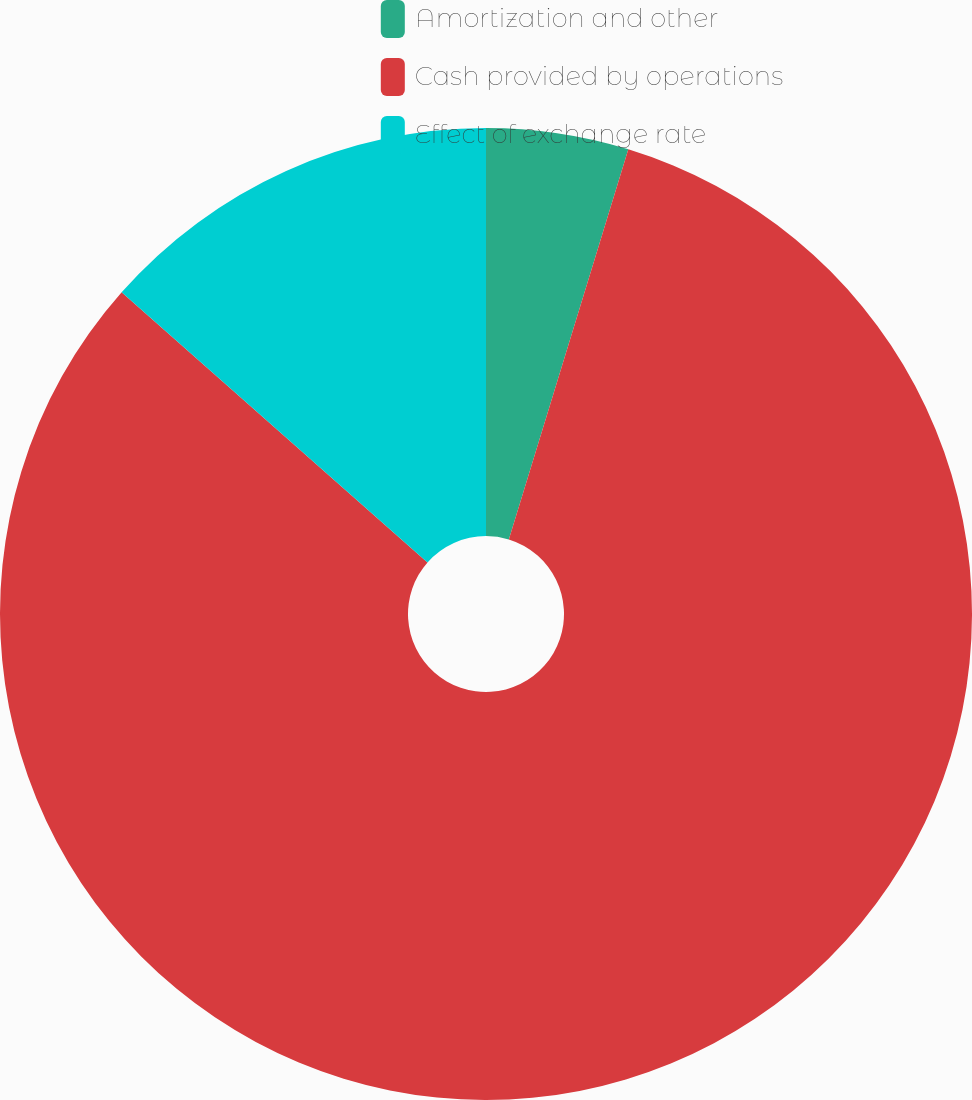Convert chart to OTSL. <chart><loc_0><loc_0><loc_500><loc_500><pie_chart><fcel>Amortization and other<fcel>Cash provided by operations<fcel>Effect of exchange rate<nl><fcel>4.73%<fcel>81.78%<fcel>13.49%<nl></chart> 